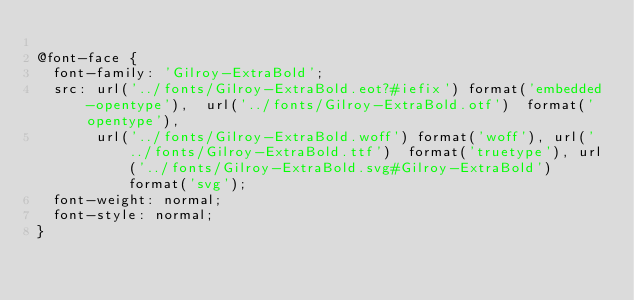Convert code to text. <code><loc_0><loc_0><loc_500><loc_500><_CSS_>
@font-face {
  font-family: 'Gilroy-ExtraBold';
  src: url('../fonts/Gilroy-ExtraBold.eot?#iefix') format('embedded-opentype'),  url('../fonts/Gilroy-ExtraBold.otf')  format('opentype'),
	     url('../fonts/Gilroy-ExtraBold.woff') format('woff'), url('../fonts/Gilroy-ExtraBold.ttf')  format('truetype'), url('../fonts/Gilroy-ExtraBold.svg#Gilroy-ExtraBold') format('svg');
  font-weight: normal;
  font-style: normal;
}
</code> 